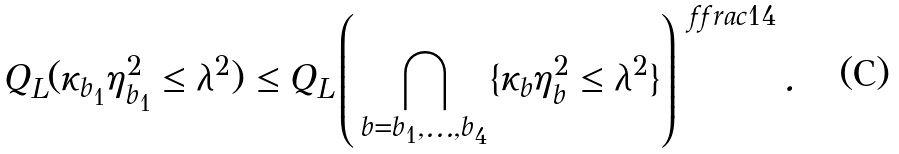<formula> <loc_0><loc_0><loc_500><loc_500>Q _ { L } ( \kappa _ { b _ { 1 } } \eta _ { b _ { 1 } } ^ { 2 } \leq \lambda ^ { 2 } ) \leq Q _ { L } \left ( \, \bigcap _ { b = b _ { 1 } , \dots , b _ { 4 } } \{ \kappa _ { b } \eta _ { b } ^ { 2 } \leq \lambda ^ { 2 } \} \right ) ^ { \ f f r a c 1 4 } .</formula> 